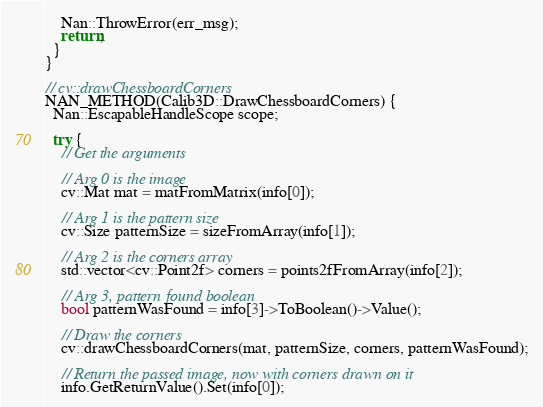<code> <loc_0><loc_0><loc_500><loc_500><_C++_>    Nan::ThrowError(err_msg);
    return;
  }
}

// cv::drawChessboardCorners
NAN_METHOD(Calib3D::DrawChessboardCorners) {
  Nan::EscapableHandleScope scope;

  try {
    // Get the arguments

    // Arg 0 is the image
    cv::Mat mat = matFromMatrix(info[0]);

    // Arg 1 is the pattern size
    cv::Size patternSize = sizeFromArray(info[1]);

    // Arg 2 is the corners array
    std::vector<cv::Point2f> corners = points2fFromArray(info[2]);

    // Arg 3, pattern found boolean
    bool patternWasFound = info[3]->ToBoolean()->Value();

    // Draw the corners
    cv::drawChessboardCorners(mat, patternSize, corners, patternWasFound);

    // Return the passed image, now with corners drawn on it
    info.GetReturnValue().Set(info[0]);
</code> 